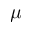Convert formula to latex. <formula><loc_0><loc_0><loc_500><loc_500>\mu</formula> 